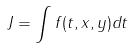<formula> <loc_0><loc_0><loc_500><loc_500>J = \int f ( t , x , y ) d t</formula> 